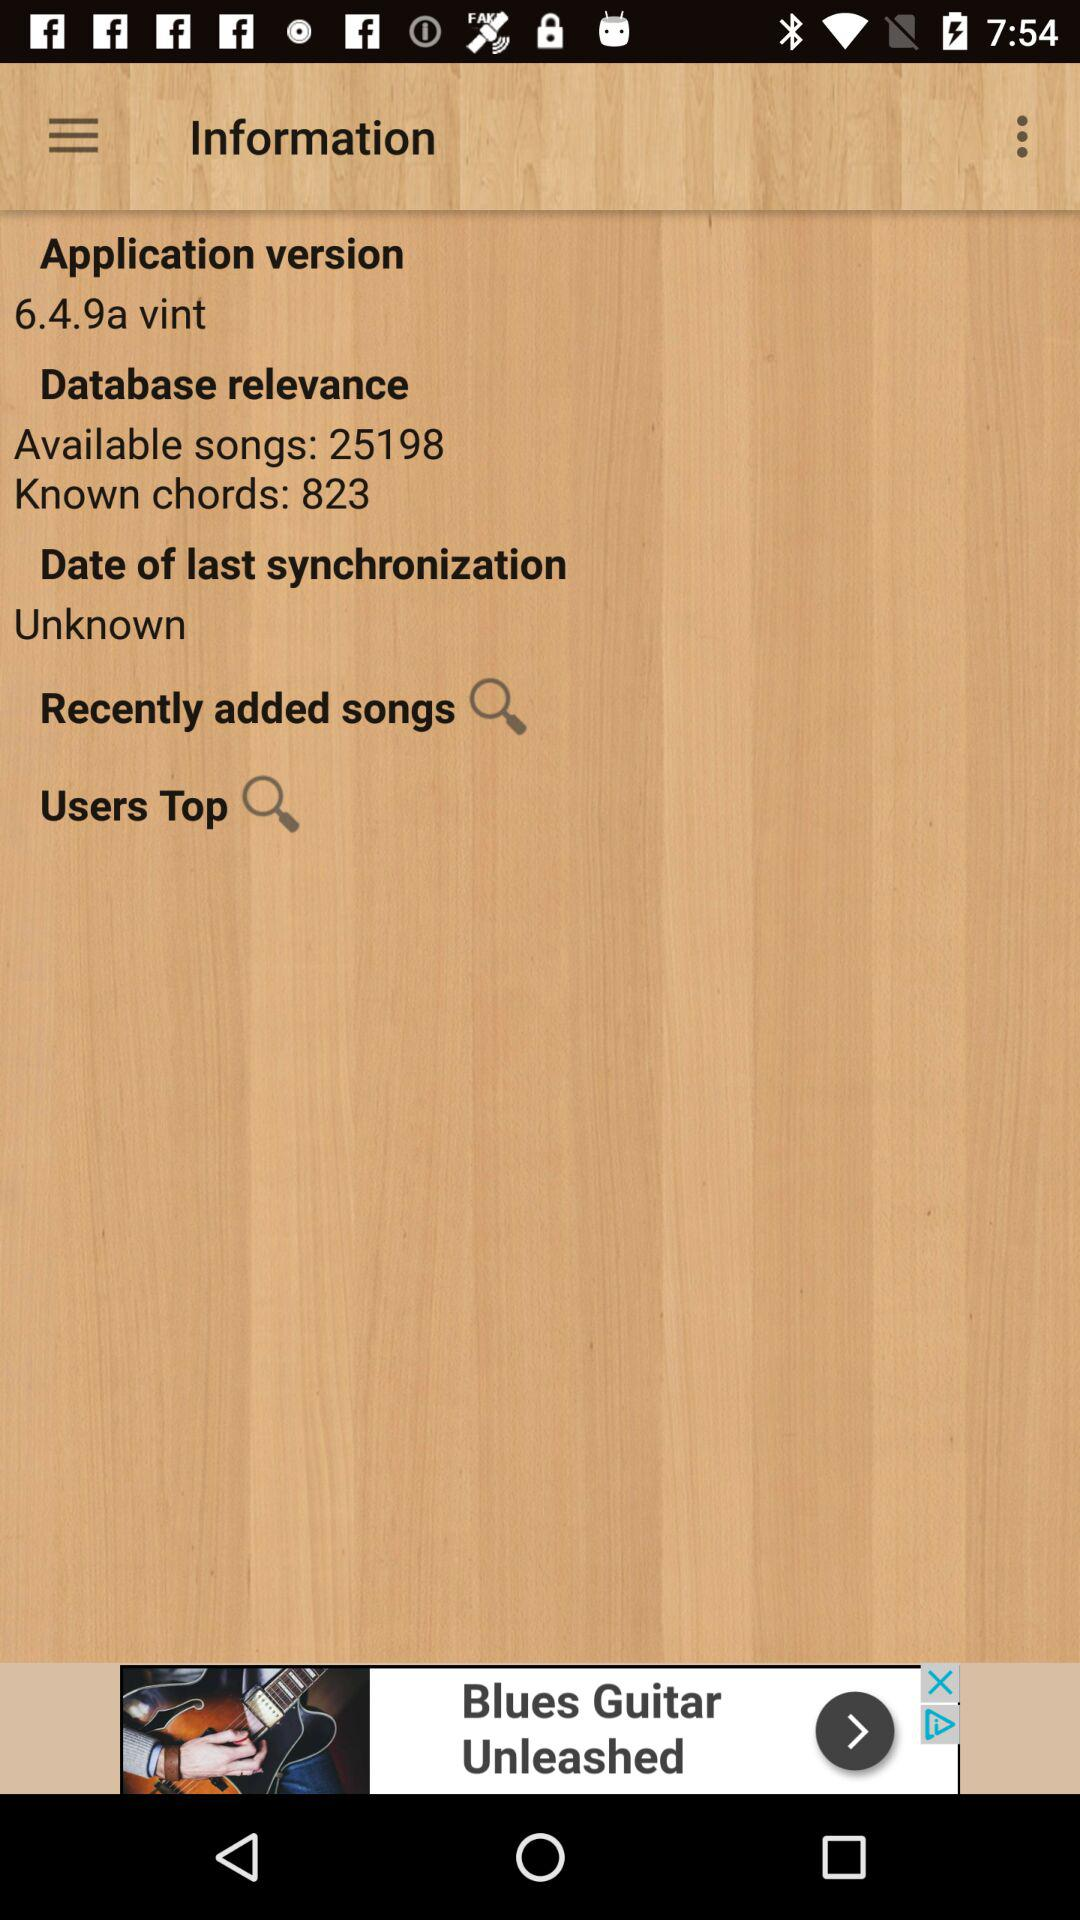What is the application version? The application version is 6.4.9a vint. 